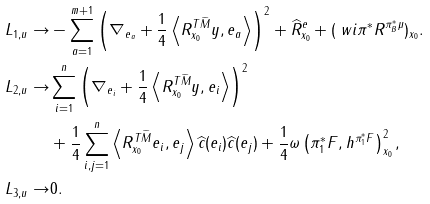Convert formula to latex. <formula><loc_0><loc_0><loc_500><loc_500>L _ { 1 , u } \to & - \sum _ { a = 1 } ^ { m + 1 } \left ( \nabla _ { e _ { a } } + \frac { 1 } { 4 } \left \langle R ^ { T \widetilde { M } } _ { x _ { 0 } } y , e _ { a } \right \rangle \right ) ^ { 2 } + \widehat { R } ^ { e } _ { x _ { 0 } } + ( \ w i { \pi } ^ { * } R ^ { \pi _ { B } ^ { * } \mu } ) _ { x _ { 0 } } . \\ L _ { 2 , u } \to & \sum _ { i = 1 } ^ { n } \left ( \nabla _ { e _ { i } } + \frac { 1 } { 4 } \left \langle R ^ { T \widetilde { M } } _ { x _ { 0 } } y , e _ { i } \right \rangle \right ) ^ { 2 } \\ & + \frac { 1 } { 4 } \sum _ { i , j = 1 } ^ { n } \left \langle R ^ { T \widetilde { M } } _ { x _ { 0 } } e _ { i } , e _ { j } \right \rangle \widehat { c } ( e _ { i } ) \widehat { c } ( e _ { j } ) + \frac { 1 } { 4 } \omega \left ( \pi _ { 1 } ^ { * } F , h ^ { \pi _ { 1 } ^ { * } F } \right ) ^ { 2 } _ { x _ { 0 } } , \\ L _ { 3 , u } \to & 0 .</formula> 